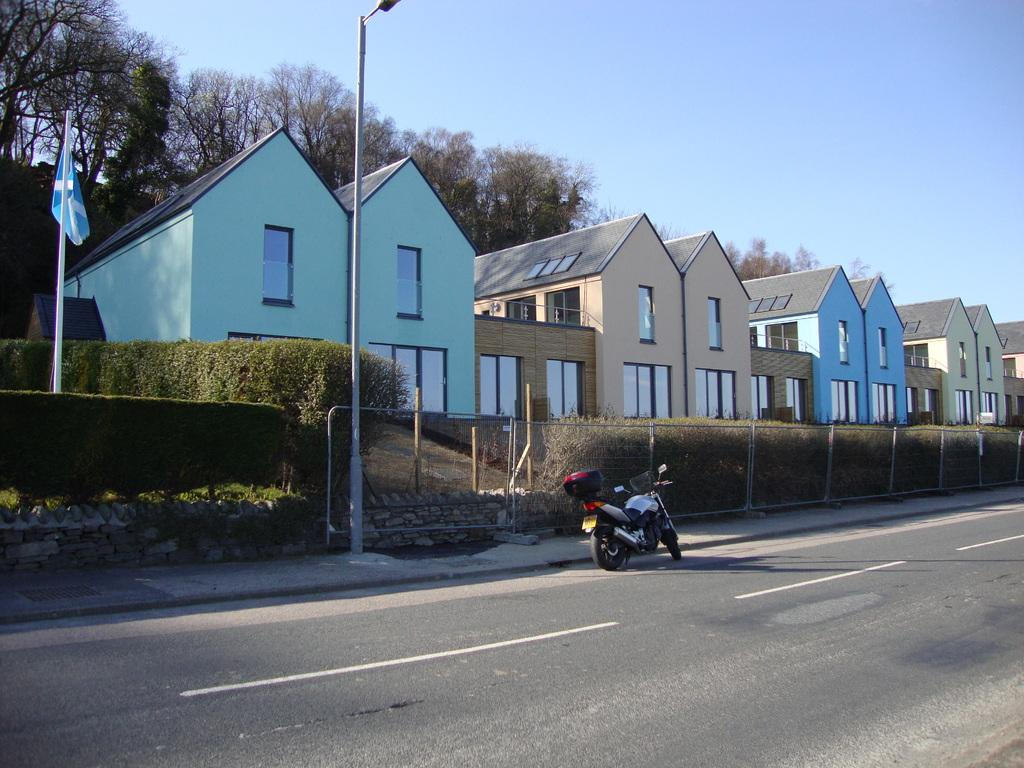What type of vehicle is on the road in the image? There is a motorcycle on the road in the image. What type of barrier can be seen in the image? There is a fence in the image. What type of pavement is present in the image? Flagstones are present in the image. What type of vegetation is visible in the image? Plants and trees are present in the image. What type of structure is in the image? Buildings with windows are in the image. What is visible in the background of the image? The sky is visible in the background of the image. What type of representative animal is present in the image? There is no representative animal present in the image. What type of birthday celebration is depicted in the image? There is no birthday celebration depicted in the image. 